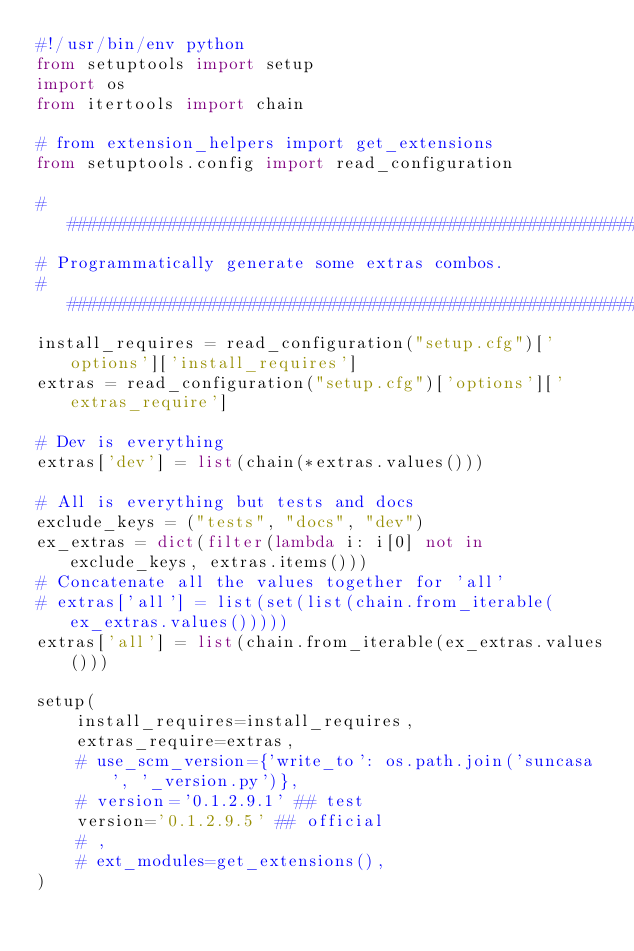Convert code to text. <code><loc_0><loc_0><loc_500><loc_500><_Python_>#!/usr/bin/env python
from setuptools import setup
import os
from itertools import chain

# from extension_helpers import get_extensions
from setuptools.config import read_configuration

################################################################################
# Programmatically generate some extras combos.
################################################################################
install_requires = read_configuration("setup.cfg")['options']['install_requires']
extras = read_configuration("setup.cfg")['options']['extras_require']

# Dev is everything
extras['dev'] = list(chain(*extras.values()))

# All is everything but tests and docs
exclude_keys = ("tests", "docs", "dev")
ex_extras = dict(filter(lambda i: i[0] not in exclude_keys, extras.items()))
# Concatenate all the values together for 'all'
# extras['all'] = list(set(list(chain.from_iterable(ex_extras.values()))))
extras['all'] = list(chain.from_iterable(ex_extras.values()))

setup(
    install_requires=install_requires,
    extras_require=extras,
    # use_scm_version={'write_to': os.path.join('suncasa', '_version.py')},
    # version='0.1.2.9.1' ## test
    version='0.1.2.9.5' ## official
    # ,
    # ext_modules=get_extensions(),
)
</code> 